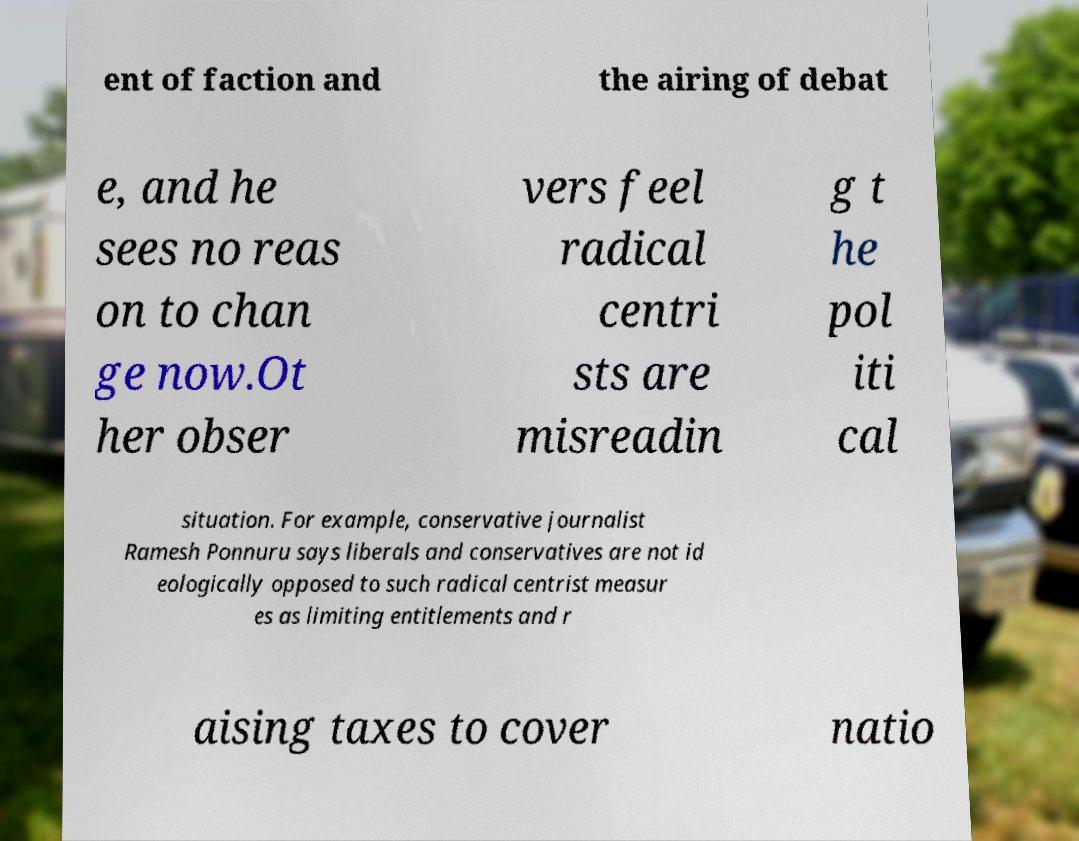Could you assist in decoding the text presented in this image and type it out clearly? ent of faction and the airing of debat e, and he sees no reas on to chan ge now.Ot her obser vers feel radical centri sts are misreadin g t he pol iti cal situation. For example, conservative journalist Ramesh Ponnuru says liberals and conservatives are not id eologically opposed to such radical centrist measur es as limiting entitlements and r aising taxes to cover natio 